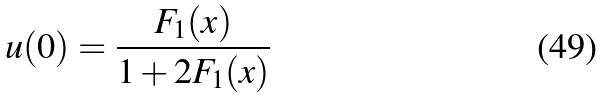Convert formula to latex. <formula><loc_0><loc_0><loc_500><loc_500>u ( 0 ) = \frac { F _ { 1 } ( x ) } { 1 + 2 F _ { 1 } ( x ) }</formula> 